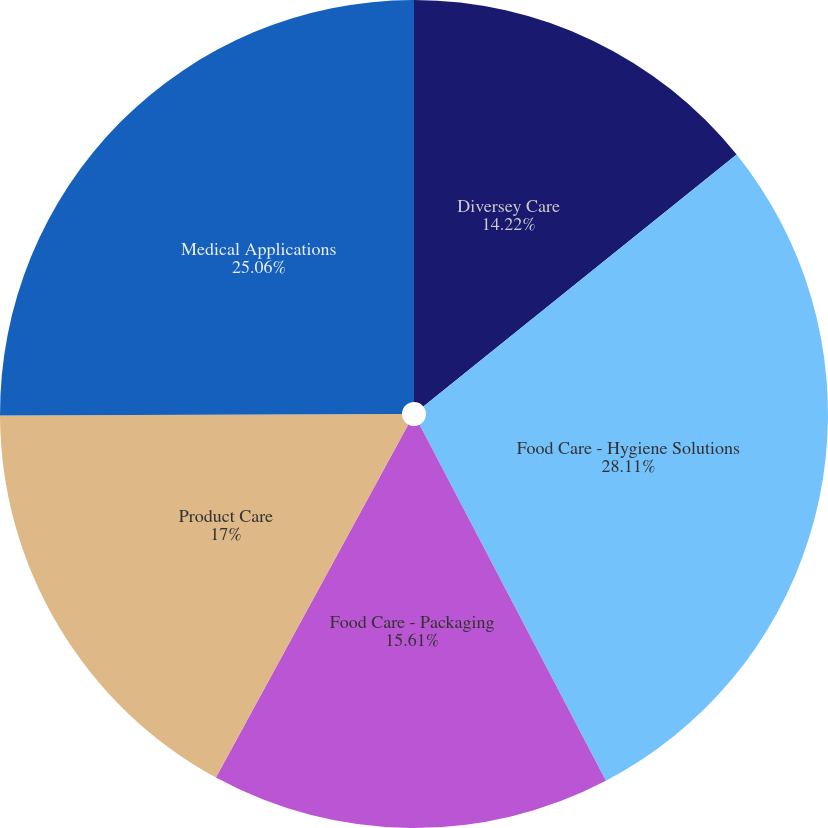Convert chart. <chart><loc_0><loc_0><loc_500><loc_500><pie_chart><fcel>Diversey Care<fcel>Food Care - Hygiene Solutions<fcel>Food Care - Packaging<fcel>Product Care<fcel>Medical Applications<nl><fcel>14.22%<fcel>28.11%<fcel>15.61%<fcel>17.0%<fcel>25.06%<nl></chart> 